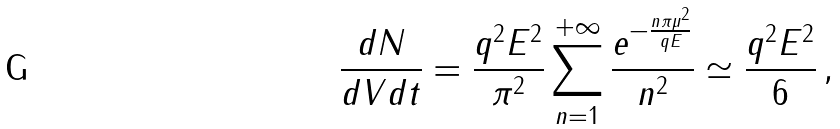Convert formula to latex. <formula><loc_0><loc_0><loc_500><loc_500>\frac { d N } { d V d t } = \frac { q ^ { 2 } E ^ { 2 } } { \pi ^ { 2 } } \sum _ { n = 1 } ^ { + \infty } { \frac { e ^ { - \frac { n \pi \mu ^ { 2 } } { q E } } } { n ^ { 2 } } } \simeq \frac { q ^ { 2 } E ^ { 2 } } { 6 } \, ,</formula> 